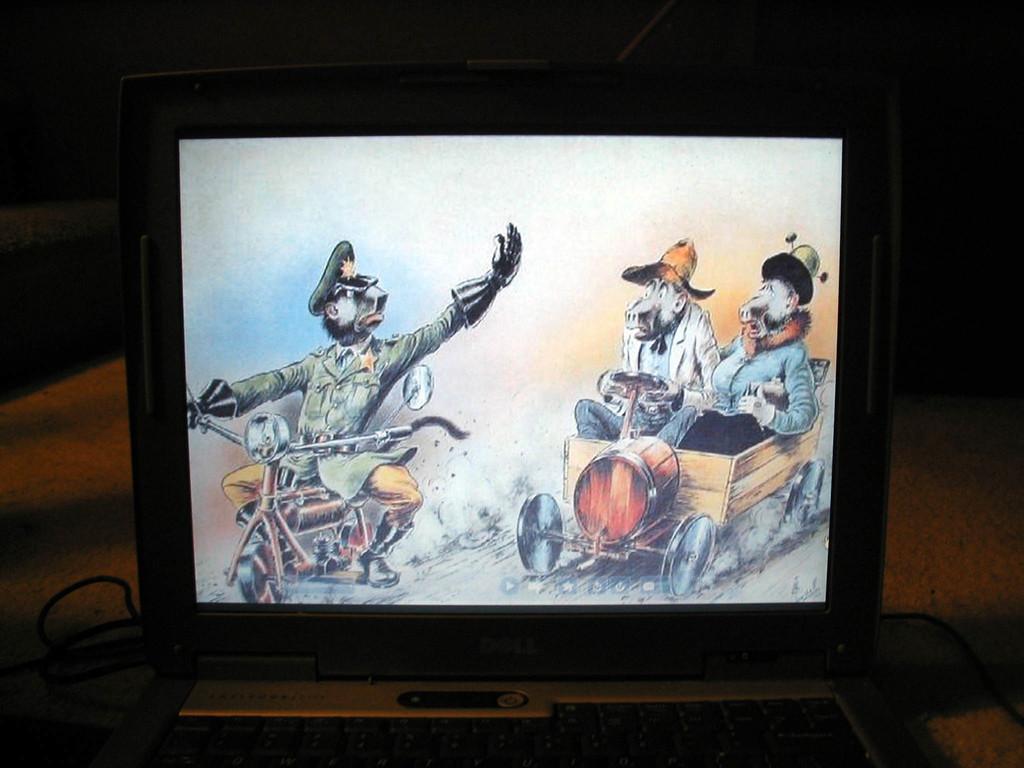What brand is the laptop?
Provide a short and direct response. Dell. 